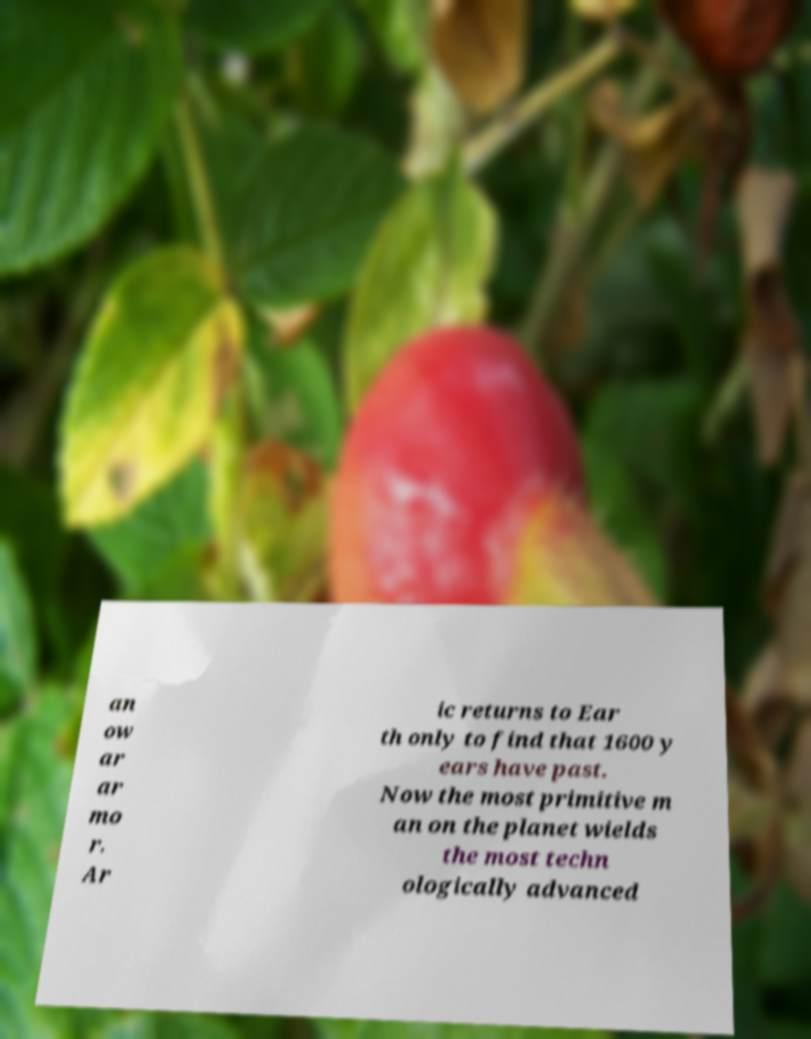Can you accurately transcribe the text from the provided image for me? an ow ar ar mo r. Ar ic returns to Ear th only to find that 1600 y ears have past. Now the most primitive m an on the planet wields the most techn ologically advanced 